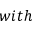Convert formula to latex. <formula><loc_0><loc_0><loc_500><loc_500>w i t h</formula> 